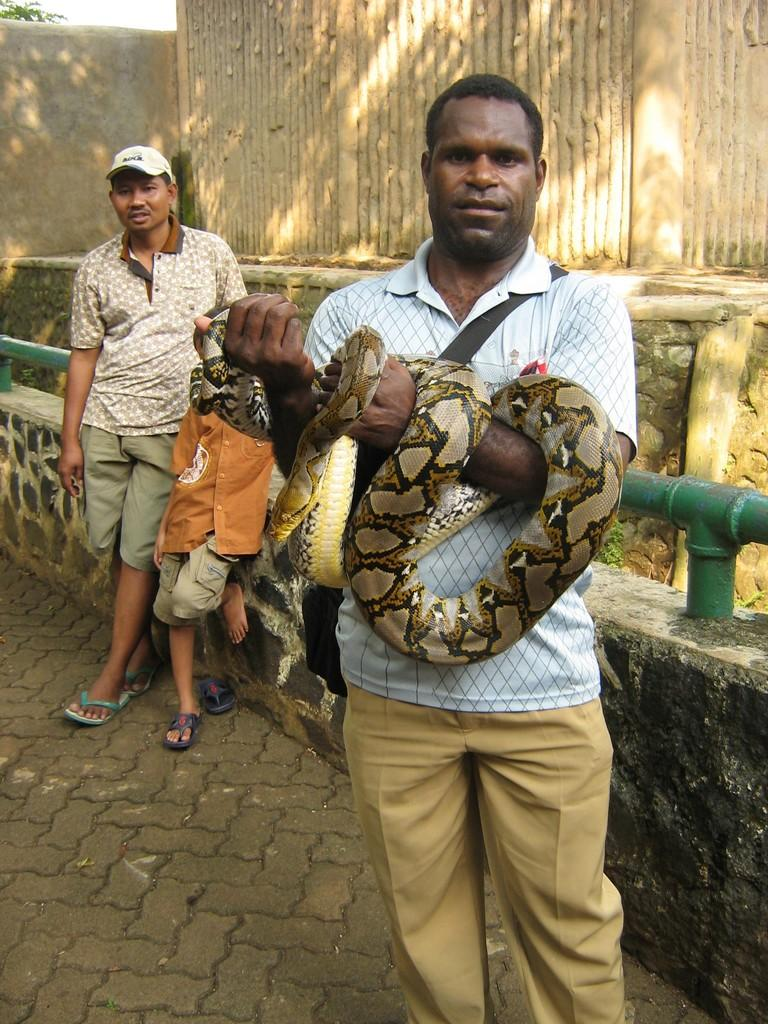What is the person holding in the image? The person is holding a snake in the image. What object can be seen in the image besides the snake? There is a rod in the image. What can be seen in the background of the image? There is a tree in the distance in the background of the image. How many other people are present in the image? Two other persons are standing nearby in the image. What type of headwear is the person holding the snake wearing? The person holding the snake is wearing a cap. How many dimes are scattered on the ground in the image? There are no dimes visible on the ground in the image. What type of creature is the person holding in the image? The person is holding a snake, which is not a creature but a reptile. 